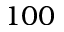<formula> <loc_0><loc_0><loc_500><loc_500>1 0 0</formula> 